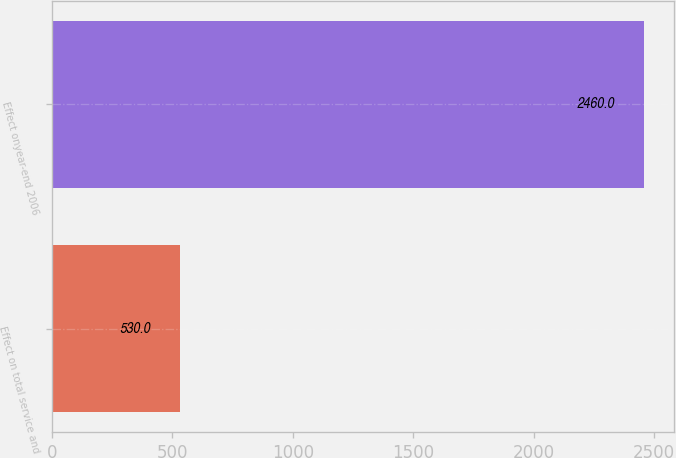Convert chart to OTSL. <chart><loc_0><loc_0><loc_500><loc_500><bar_chart><fcel>Effect on total service and<fcel>Effect onyear-end 2006<nl><fcel>530<fcel>2460<nl></chart> 